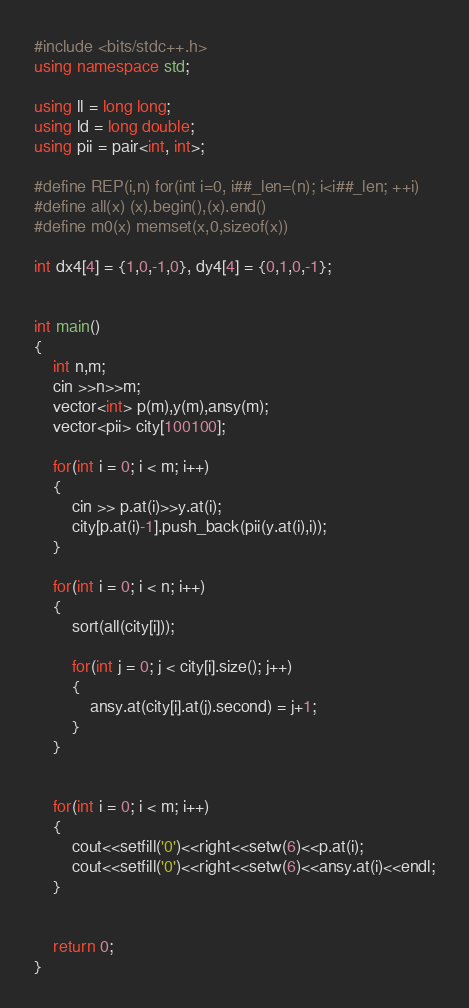<code> <loc_0><loc_0><loc_500><loc_500><_C++_>#include <bits/stdc++.h>
using namespace std;

using ll = long long;
using ld = long double;
using pii = pair<int, int>;

#define REP(i,n) for(int i=0, i##_len=(n); i<i##_len; ++i)
#define all(x) (x).begin(),(x).end()
#define m0(x) memset(x,0,sizeof(x))

int dx4[4] = {1,0,-1,0}, dy4[4] = {0,1,0,-1};


int main()
{
    int n,m;
    cin >>n>>m;
    vector<int> p(m),y(m),ansy(m);
    vector<pii> city[100100];
    
    for(int i = 0; i < m; i++)
    {
        cin >> p.at(i)>>y.at(i);
        city[p.at(i)-1].push_back(pii(y.at(i),i));
    }
    
    for(int i = 0; i < n; i++)
    {
        sort(all(city[i]));
        
        for(int j = 0; j < city[i].size(); j++)
        {
            ansy.at(city[i].at(j).second) = j+1;
        }        
    }
    
    
    for(int i = 0; i < m; i++)
    {
        cout<<setfill('0')<<right<<setw(6)<<p.at(i);
        cout<<setfill('0')<<right<<setw(6)<<ansy.at(i)<<endl;
    }
    
 
    return 0;
}</code> 